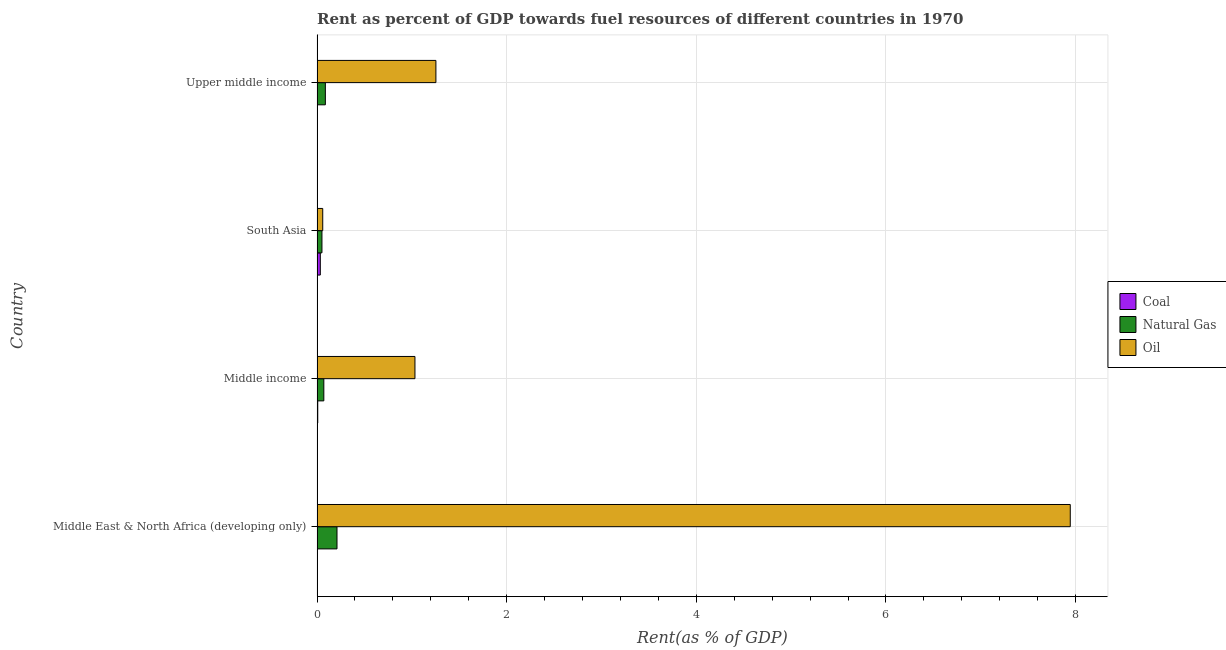How many groups of bars are there?
Your answer should be compact. 4. Are the number of bars per tick equal to the number of legend labels?
Your answer should be very brief. Yes. Are the number of bars on each tick of the Y-axis equal?
Offer a very short reply. Yes. What is the label of the 4th group of bars from the top?
Offer a very short reply. Middle East & North Africa (developing only). In how many cases, is the number of bars for a given country not equal to the number of legend labels?
Offer a very short reply. 0. What is the rent towards oil in South Asia?
Ensure brevity in your answer.  0.06. Across all countries, what is the maximum rent towards coal?
Provide a succinct answer. 0.03. Across all countries, what is the minimum rent towards oil?
Provide a short and direct response. 0.06. What is the total rent towards coal in the graph?
Your response must be concise. 0.04. What is the difference between the rent towards coal in Middle East & North Africa (developing only) and that in South Asia?
Your answer should be compact. -0.03. What is the difference between the rent towards natural gas in Middle income and the rent towards coal in Upper middle income?
Give a very brief answer. 0.07. What is the average rent towards natural gas per country?
Make the answer very short. 0.1. What is the difference between the rent towards natural gas and rent towards coal in South Asia?
Make the answer very short. 0.02. In how many countries, is the rent towards coal greater than 7.2 %?
Make the answer very short. 0. What is the ratio of the rent towards coal in Middle income to that in Upper middle income?
Give a very brief answer. 40.36. Is the difference between the rent towards natural gas in Middle income and Upper middle income greater than the difference between the rent towards oil in Middle income and Upper middle income?
Give a very brief answer. Yes. What is the difference between the highest and the second highest rent towards oil?
Give a very brief answer. 6.69. What is the difference between the highest and the lowest rent towards oil?
Keep it short and to the point. 7.88. Is the sum of the rent towards natural gas in Middle East & North Africa (developing only) and Upper middle income greater than the maximum rent towards oil across all countries?
Provide a short and direct response. No. What does the 2nd bar from the top in Middle East & North Africa (developing only) represents?
Offer a very short reply. Natural Gas. What does the 1st bar from the bottom in Upper middle income represents?
Ensure brevity in your answer.  Coal. Is it the case that in every country, the sum of the rent towards coal and rent towards natural gas is greater than the rent towards oil?
Your answer should be very brief. No. How many bars are there?
Offer a terse response. 12. Are all the bars in the graph horizontal?
Ensure brevity in your answer.  Yes. How many countries are there in the graph?
Offer a very short reply. 4. What is the difference between two consecutive major ticks on the X-axis?
Provide a short and direct response. 2. Are the values on the major ticks of X-axis written in scientific E-notation?
Your answer should be compact. No. Does the graph contain grids?
Provide a succinct answer. Yes. What is the title of the graph?
Offer a very short reply. Rent as percent of GDP towards fuel resources of different countries in 1970. Does "Social Insurance" appear as one of the legend labels in the graph?
Your response must be concise. No. What is the label or title of the X-axis?
Offer a terse response. Rent(as % of GDP). What is the Rent(as % of GDP) of Coal in Middle East & North Africa (developing only)?
Your response must be concise. 0. What is the Rent(as % of GDP) in Natural Gas in Middle East & North Africa (developing only)?
Keep it short and to the point. 0.21. What is the Rent(as % of GDP) of Oil in Middle East & North Africa (developing only)?
Offer a very short reply. 7.94. What is the Rent(as % of GDP) of Coal in Middle income?
Give a very brief answer. 0.01. What is the Rent(as % of GDP) in Natural Gas in Middle income?
Your answer should be compact. 0.07. What is the Rent(as % of GDP) of Oil in Middle income?
Give a very brief answer. 1.03. What is the Rent(as % of GDP) of Coal in South Asia?
Ensure brevity in your answer.  0.03. What is the Rent(as % of GDP) of Natural Gas in South Asia?
Offer a terse response. 0.05. What is the Rent(as % of GDP) of Oil in South Asia?
Ensure brevity in your answer.  0.06. What is the Rent(as % of GDP) in Coal in Upper middle income?
Give a very brief answer. 0. What is the Rent(as % of GDP) in Natural Gas in Upper middle income?
Offer a terse response. 0.09. What is the Rent(as % of GDP) of Oil in Upper middle income?
Offer a very short reply. 1.25. Across all countries, what is the maximum Rent(as % of GDP) of Coal?
Your answer should be very brief. 0.03. Across all countries, what is the maximum Rent(as % of GDP) of Natural Gas?
Give a very brief answer. 0.21. Across all countries, what is the maximum Rent(as % of GDP) of Oil?
Your response must be concise. 7.94. Across all countries, what is the minimum Rent(as % of GDP) of Coal?
Provide a short and direct response. 0. Across all countries, what is the minimum Rent(as % of GDP) of Natural Gas?
Provide a succinct answer. 0.05. Across all countries, what is the minimum Rent(as % of GDP) in Oil?
Ensure brevity in your answer.  0.06. What is the total Rent(as % of GDP) of Coal in the graph?
Provide a succinct answer. 0.04. What is the total Rent(as % of GDP) of Natural Gas in the graph?
Ensure brevity in your answer.  0.42. What is the total Rent(as % of GDP) in Oil in the graph?
Your answer should be very brief. 10.29. What is the difference between the Rent(as % of GDP) in Coal in Middle East & North Africa (developing only) and that in Middle income?
Provide a succinct answer. -0.01. What is the difference between the Rent(as % of GDP) of Natural Gas in Middle East & North Africa (developing only) and that in Middle income?
Provide a succinct answer. 0.14. What is the difference between the Rent(as % of GDP) in Oil in Middle East & North Africa (developing only) and that in Middle income?
Make the answer very short. 6.91. What is the difference between the Rent(as % of GDP) of Coal in Middle East & North Africa (developing only) and that in South Asia?
Provide a short and direct response. -0.03. What is the difference between the Rent(as % of GDP) in Natural Gas in Middle East & North Africa (developing only) and that in South Asia?
Your answer should be very brief. 0.16. What is the difference between the Rent(as % of GDP) in Oil in Middle East & North Africa (developing only) and that in South Asia?
Keep it short and to the point. 7.88. What is the difference between the Rent(as % of GDP) of Coal in Middle East & North Africa (developing only) and that in Upper middle income?
Keep it short and to the point. 0. What is the difference between the Rent(as % of GDP) of Natural Gas in Middle East & North Africa (developing only) and that in Upper middle income?
Your answer should be very brief. 0.12. What is the difference between the Rent(as % of GDP) of Oil in Middle East & North Africa (developing only) and that in Upper middle income?
Your answer should be compact. 6.69. What is the difference between the Rent(as % of GDP) of Coal in Middle income and that in South Asia?
Your answer should be very brief. -0.03. What is the difference between the Rent(as % of GDP) in Natural Gas in Middle income and that in South Asia?
Your answer should be very brief. 0.02. What is the difference between the Rent(as % of GDP) of Oil in Middle income and that in South Asia?
Provide a succinct answer. 0.97. What is the difference between the Rent(as % of GDP) of Coal in Middle income and that in Upper middle income?
Your response must be concise. 0.01. What is the difference between the Rent(as % of GDP) of Natural Gas in Middle income and that in Upper middle income?
Give a very brief answer. -0.02. What is the difference between the Rent(as % of GDP) of Oil in Middle income and that in Upper middle income?
Offer a very short reply. -0.22. What is the difference between the Rent(as % of GDP) in Coal in South Asia and that in Upper middle income?
Give a very brief answer. 0.03. What is the difference between the Rent(as % of GDP) in Natural Gas in South Asia and that in Upper middle income?
Give a very brief answer. -0.04. What is the difference between the Rent(as % of GDP) in Oil in South Asia and that in Upper middle income?
Your response must be concise. -1.19. What is the difference between the Rent(as % of GDP) of Coal in Middle East & North Africa (developing only) and the Rent(as % of GDP) of Natural Gas in Middle income?
Offer a very short reply. -0.07. What is the difference between the Rent(as % of GDP) of Coal in Middle East & North Africa (developing only) and the Rent(as % of GDP) of Oil in Middle income?
Provide a short and direct response. -1.03. What is the difference between the Rent(as % of GDP) of Natural Gas in Middle East & North Africa (developing only) and the Rent(as % of GDP) of Oil in Middle income?
Provide a succinct answer. -0.82. What is the difference between the Rent(as % of GDP) in Coal in Middle East & North Africa (developing only) and the Rent(as % of GDP) in Natural Gas in South Asia?
Your response must be concise. -0.05. What is the difference between the Rent(as % of GDP) in Coal in Middle East & North Africa (developing only) and the Rent(as % of GDP) in Oil in South Asia?
Your answer should be compact. -0.06. What is the difference between the Rent(as % of GDP) in Natural Gas in Middle East & North Africa (developing only) and the Rent(as % of GDP) in Oil in South Asia?
Give a very brief answer. 0.15. What is the difference between the Rent(as % of GDP) in Coal in Middle East & North Africa (developing only) and the Rent(as % of GDP) in Natural Gas in Upper middle income?
Give a very brief answer. -0.09. What is the difference between the Rent(as % of GDP) of Coal in Middle East & North Africa (developing only) and the Rent(as % of GDP) of Oil in Upper middle income?
Provide a short and direct response. -1.25. What is the difference between the Rent(as % of GDP) of Natural Gas in Middle East & North Africa (developing only) and the Rent(as % of GDP) of Oil in Upper middle income?
Offer a very short reply. -1.04. What is the difference between the Rent(as % of GDP) in Coal in Middle income and the Rent(as % of GDP) in Natural Gas in South Asia?
Your answer should be compact. -0.04. What is the difference between the Rent(as % of GDP) of Coal in Middle income and the Rent(as % of GDP) of Oil in South Asia?
Provide a succinct answer. -0.05. What is the difference between the Rent(as % of GDP) of Natural Gas in Middle income and the Rent(as % of GDP) of Oil in South Asia?
Give a very brief answer. 0.01. What is the difference between the Rent(as % of GDP) in Coal in Middle income and the Rent(as % of GDP) in Natural Gas in Upper middle income?
Offer a very short reply. -0.08. What is the difference between the Rent(as % of GDP) in Coal in Middle income and the Rent(as % of GDP) in Oil in Upper middle income?
Give a very brief answer. -1.25. What is the difference between the Rent(as % of GDP) in Natural Gas in Middle income and the Rent(as % of GDP) in Oil in Upper middle income?
Provide a succinct answer. -1.18. What is the difference between the Rent(as % of GDP) in Coal in South Asia and the Rent(as % of GDP) in Natural Gas in Upper middle income?
Offer a very short reply. -0.05. What is the difference between the Rent(as % of GDP) in Coal in South Asia and the Rent(as % of GDP) in Oil in Upper middle income?
Your answer should be compact. -1.22. What is the difference between the Rent(as % of GDP) in Natural Gas in South Asia and the Rent(as % of GDP) in Oil in Upper middle income?
Provide a short and direct response. -1.2. What is the average Rent(as % of GDP) of Coal per country?
Provide a succinct answer. 0.01. What is the average Rent(as % of GDP) in Natural Gas per country?
Provide a short and direct response. 0.11. What is the average Rent(as % of GDP) in Oil per country?
Give a very brief answer. 2.57. What is the difference between the Rent(as % of GDP) in Coal and Rent(as % of GDP) in Natural Gas in Middle East & North Africa (developing only)?
Your answer should be compact. -0.21. What is the difference between the Rent(as % of GDP) in Coal and Rent(as % of GDP) in Oil in Middle East & North Africa (developing only)?
Make the answer very short. -7.94. What is the difference between the Rent(as % of GDP) of Natural Gas and Rent(as % of GDP) of Oil in Middle East & North Africa (developing only)?
Provide a short and direct response. -7.73. What is the difference between the Rent(as % of GDP) of Coal and Rent(as % of GDP) of Natural Gas in Middle income?
Ensure brevity in your answer.  -0.06. What is the difference between the Rent(as % of GDP) in Coal and Rent(as % of GDP) in Oil in Middle income?
Provide a short and direct response. -1.02. What is the difference between the Rent(as % of GDP) in Natural Gas and Rent(as % of GDP) in Oil in Middle income?
Your answer should be compact. -0.96. What is the difference between the Rent(as % of GDP) of Coal and Rent(as % of GDP) of Natural Gas in South Asia?
Provide a short and direct response. -0.02. What is the difference between the Rent(as % of GDP) in Coal and Rent(as % of GDP) in Oil in South Asia?
Offer a terse response. -0.03. What is the difference between the Rent(as % of GDP) of Natural Gas and Rent(as % of GDP) of Oil in South Asia?
Offer a terse response. -0.01. What is the difference between the Rent(as % of GDP) of Coal and Rent(as % of GDP) of Natural Gas in Upper middle income?
Offer a very short reply. -0.09. What is the difference between the Rent(as % of GDP) of Coal and Rent(as % of GDP) of Oil in Upper middle income?
Give a very brief answer. -1.25. What is the difference between the Rent(as % of GDP) of Natural Gas and Rent(as % of GDP) of Oil in Upper middle income?
Ensure brevity in your answer.  -1.17. What is the ratio of the Rent(as % of GDP) in Coal in Middle East & North Africa (developing only) to that in Middle income?
Your answer should be compact. 0.11. What is the ratio of the Rent(as % of GDP) of Natural Gas in Middle East & North Africa (developing only) to that in Middle income?
Offer a very short reply. 2.94. What is the ratio of the Rent(as % of GDP) in Oil in Middle East & North Africa (developing only) to that in Middle income?
Your answer should be compact. 7.69. What is the ratio of the Rent(as % of GDP) of Coal in Middle East & North Africa (developing only) to that in South Asia?
Offer a very short reply. 0.02. What is the ratio of the Rent(as % of GDP) of Natural Gas in Middle East & North Africa (developing only) to that in South Asia?
Make the answer very short. 4.07. What is the ratio of the Rent(as % of GDP) in Oil in Middle East & North Africa (developing only) to that in South Asia?
Provide a short and direct response. 132.59. What is the ratio of the Rent(as % of GDP) in Coal in Middle East & North Africa (developing only) to that in Upper middle income?
Ensure brevity in your answer.  4.47. What is the ratio of the Rent(as % of GDP) in Natural Gas in Middle East & North Africa (developing only) to that in Upper middle income?
Keep it short and to the point. 2.4. What is the ratio of the Rent(as % of GDP) of Oil in Middle East & North Africa (developing only) to that in Upper middle income?
Your response must be concise. 6.34. What is the ratio of the Rent(as % of GDP) in Coal in Middle income to that in South Asia?
Offer a terse response. 0.22. What is the ratio of the Rent(as % of GDP) in Natural Gas in Middle income to that in South Asia?
Provide a short and direct response. 1.38. What is the ratio of the Rent(as % of GDP) of Oil in Middle income to that in South Asia?
Make the answer very short. 17.23. What is the ratio of the Rent(as % of GDP) in Coal in Middle income to that in Upper middle income?
Your answer should be compact. 40.36. What is the ratio of the Rent(as % of GDP) in Natural Gas in Middle income to that in Upper middle income?
Keep it short and to the point. 0.82. What is the ratio of the Rent(as % of GDP) in Oil in Middle income to that in Upper middle income?
Offer a terse response. 0.82. What is the ratio of the Rent(as % of GDP) of Coal in South Asia to that in Upper middle income?
Your response must be concise. 187.05. What is the ratio of the Rent(as % of GDP) of Natural Gas in South Asia to that in Upper middle income?
Your answer should be compact. 0.59. What is the ratio of the Rent(as % of GDP) of Oil in South Asia to that in Upper middle income?
Your answer should be compact. 0.05. What is the difference between the highest and the second highest Rent(as % of GDP) in Coal?
Your answer should be very brief. 0.03. What is the difference between the highest and the second highest Rent(as % of GDP) of Natural Gas?
Provide a short and direct response. 0.12. What is the difference between the highest and the second highest Rent(as % of GDP) in Oil?
Your answer should be very brief. 6.69. What is the difference between the highest and the lowest Rent(as % of GDP) of Coal?
Make the answer very short. 0.03. What is the difference between the highest and the lowest Rent(as % of GDP) of Natural Gas?
Ensure brevity in your answer.  0.16. What is the difference between the highest and the lowest Rent(as % of GDP) in Oil?
Provide a succinct answer. 7.88. 